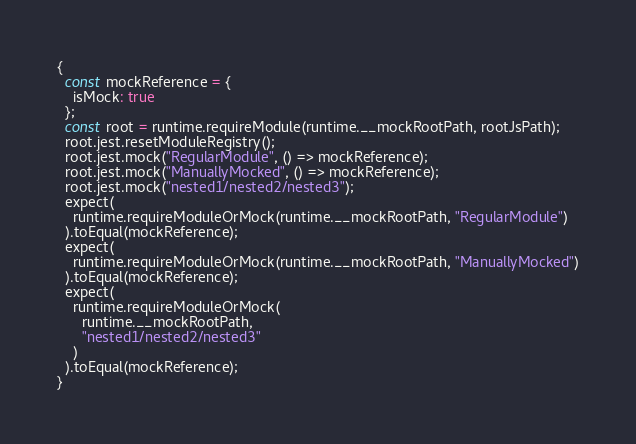<code> <loc_0><loc_0><loc_500><loc_500><_JavaScript_>{
  const mockReference = {
    isMock: true
  };
  const root = runtime.requireModule(runtime.__mockRootPath, rootJsPath);
  root.jest.resetModuleRegistry();
  root.jest.mock("RegularModule", () => mockReference);
  root.jest.mock("ManuallyMocked", () => mockReference);
  root.jest.mock("nested1/nested2/nested3");
  expect(
    runtime.requireModuleOrMock(runtime.__mockRootPath, "RegularModule")
  ).toEqual(mockReference);
  expect(
    runtime.requireModuleOrMock(runtime.__mockRootPath, "ManuallyMocked")
  ).toEqual(mockReference);
  expect(
    runtime.requireModuleOrMock(
      runtime.__mockRootPath,
      "nested1/nested2/nested3"
    )
  ).toEqual(mockReference);
}
</code> 